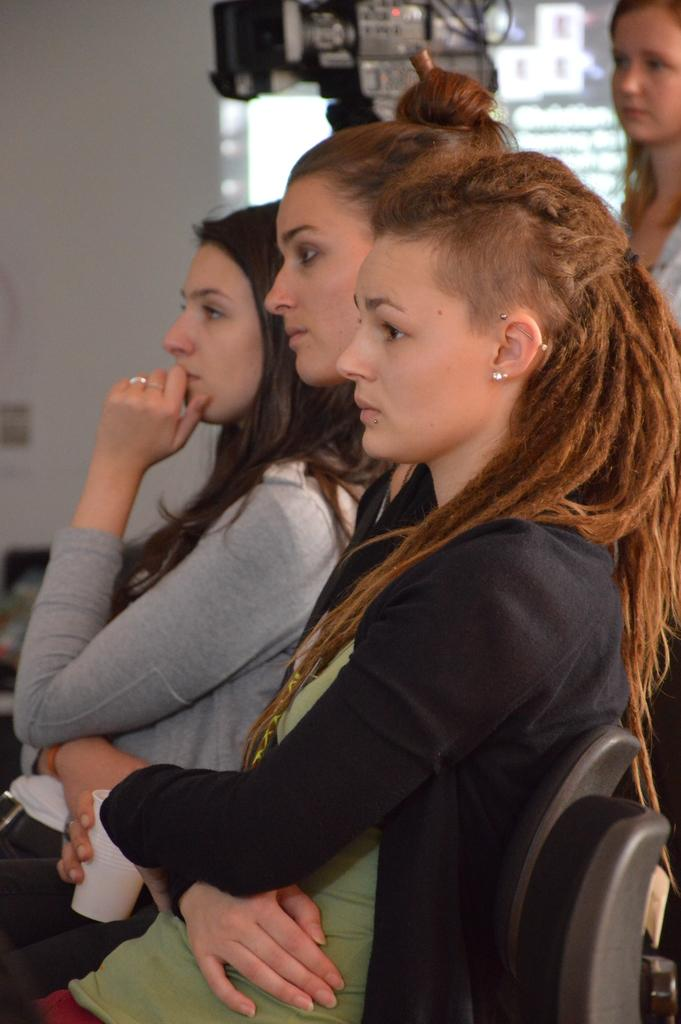How many girls are present in the image? There are three girls in the image. What are the girls sitting on? The girls are sitting on black chairs. What direction are the girls looking in? The girls are looking straight. What can be seen in the image besides the girls? There is a black color camera in the image. Are there any other people in the image? Yes, there is another girl in the image, also looking straight. What type of brick is being used to build the pickle in the image? There is no brick or pickle present in the image. 